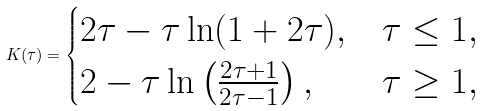Convert formula to latex. <formula><loc_0><loc_0><loc_500><loc_500>K ( \tau ) = \begin{cases} 2 \tau - \tau \ln ( 1 + 2 \tau ) , & \tau \leq 1 , \\ 2 - \tau \ln \left ( \frac { 2 \tau + 1 } { 2 \tau - 1 } \right ) , & \tau \geq 1 , \end{cases}</formula> 